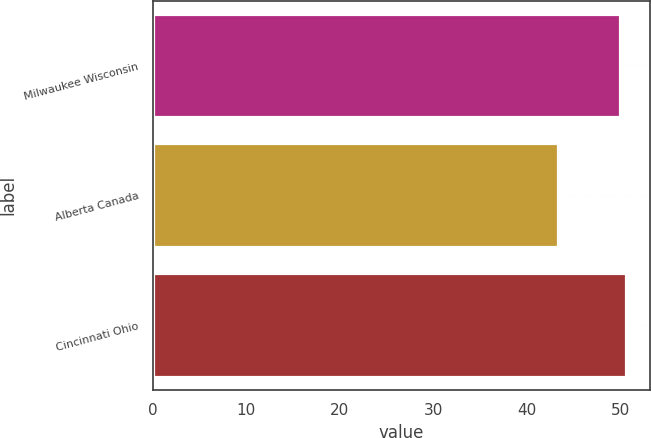Convert chart. <chart><loc_0><loc_0><loc_500><loc_500><bar_chart><fcel>Milwaukee Wisconsin<fcel>Alberta Canada<fcel>Cincinnati Ohio<nl><fcel>50<fcel>43.37<fcel>50.66<nl></chart> 